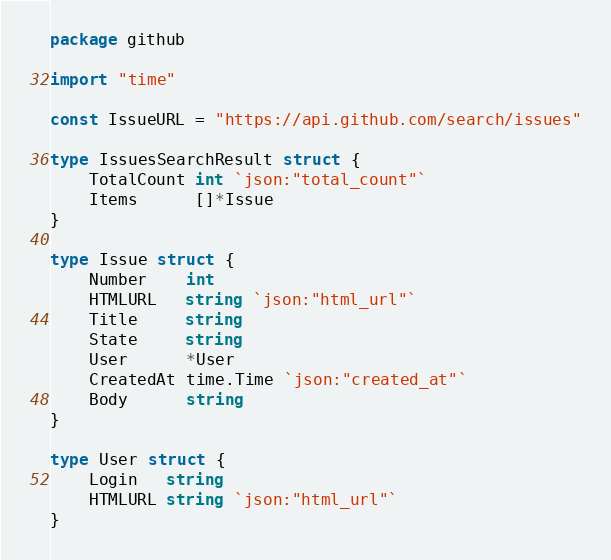Convert code to text. <code><loc_0><loc_0><loc_500><loc_500><_Go_>package github

import "time"

const IssueURL = "https://api.github.com/search/issues"

type IssuesSearchResult struct {
	TotalCount int `json:"total_count"`
	Items      []*Issue
}

type Issue struct {
	Number    int
	HTMLURL   string `json:"html_url"`
	Title     string
	State     string
	User      *User
	CreatedAt time.Time `json:"created_at"`
	Body      string
}

type User struct {
	Login   string
	HTMLURL string `json:"html_url"`
}
</code> 